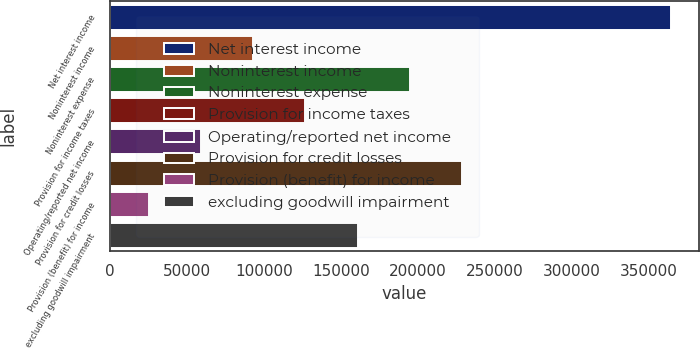<chart> <loc_0><loc_0><loc_500><loc_500><bar_chart><fcel>Net interest income<fcel>Noninterest income<fcel>Noninterest expense<fcel>Provision for income taxes<fcel>Operating/reported net income<fcel>Provision for credit losses<fcel>Provision (benefit) for income<fcel>excluding goodwill impairment<nl><fcel>364449<fcel>92916.2<fcel>194741<fcel>126858<fcel>58974.6<fcel>228683<fcel>25033<fcel>160799<nl></chart> 